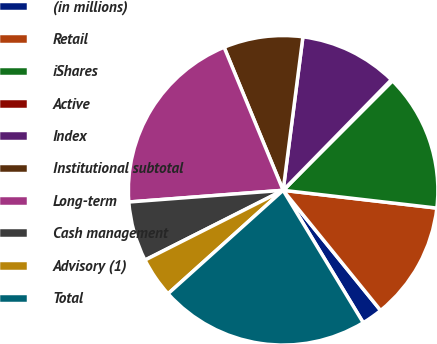Convert chart to OTSL. <chart><loc_0><loc_0><loc_500><loc_500><pie_chart><fcel>(in millions)<fcel>Retail<fcel>iShares<fcel>Active<fcel>Index<fcel>Institutional subtotal<fcel>Long-term<fcel>Cash management<fcel>Advisory (1)<fcel>Total<nl><fcel>2.19%<fcel>12.32%<fcel>14.35%<fcel>0.16%<fcel>10.29%<fcel>8.27%<fcel>19.98%<fcel>6.24%<fcel>4.21%<fcel>22.01%<nl></chart> 